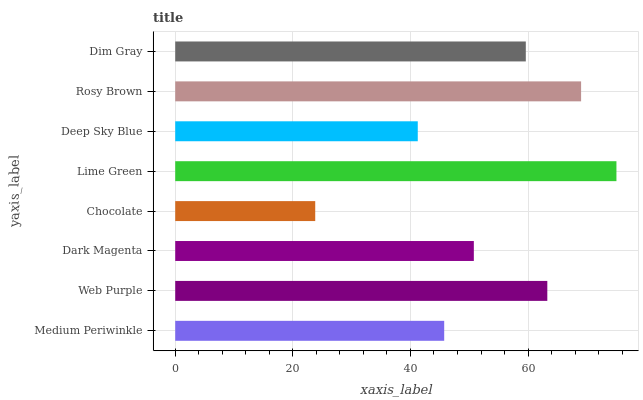Is Chocolate the minimum?
Answer yes or no. Yes. Is Lime Green the maximum?
Answer yes or no. Yes. Is Web Purple the minimum?
Answer yes or no. No. Is Web Purple the maximum?
Answer yes or no. No. Is Web Purple greater than Medium Periwinkle?
Answer yes or no. Yes. Is Medium Periwinkle less than Web Purple?
Answer yes or no. Yes. Is Medium Periwinkle greater than Web Purple?
Answer yes or no. No. Is Web Purple less than Medium Periwinkle?
Answer yes or no. No. Is Dim Gray the high median?
Answer yes or no. Yes. Is Dark Magenta the low median?
Answer yes or no. Yes. Is Dark Magenta the high median?
Answer yes or no. No. Is Web Purple the low median?
Answer yes or no. No. 